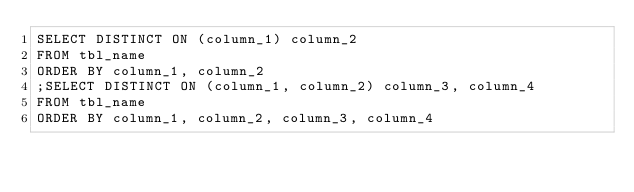Convert code to text. <code><loc_0><loc_0><loc_500><loc_500><_SQL_>SELECT DISTINCT ON (column_1) column_2
FROM tbl_name
ORDER BY column_1, column_2
;SELECT DISTINCT ON (column_1, column_2) column_3, column_4
FROM tbl_name
ORDER BY column_1, column_2, column_3, column_4
</code> 